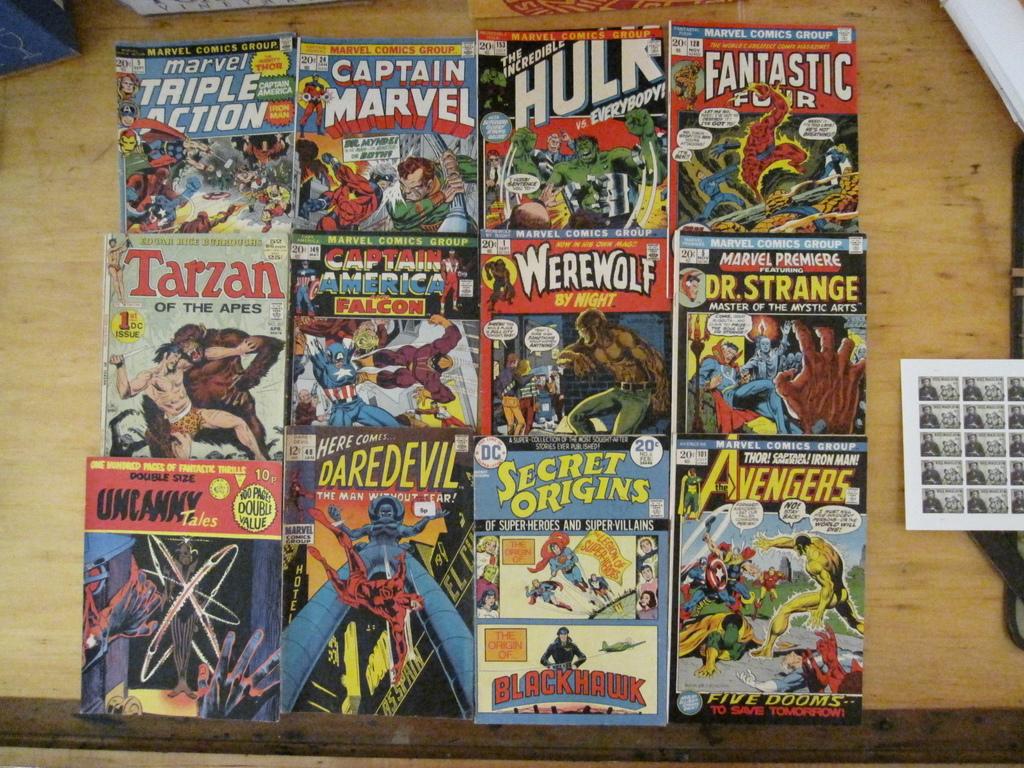Who is featured in the comic 2nd from right in 2nd row?
Keep it short and to the point. Werewolf. 